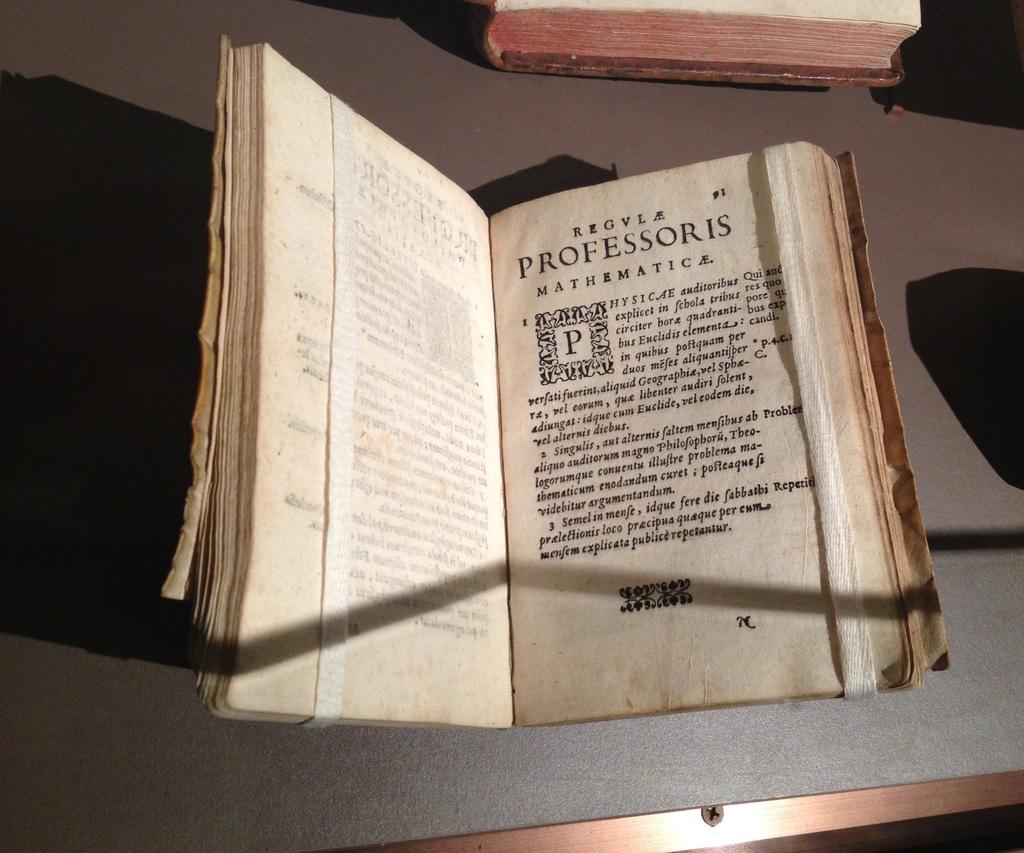What is this book about?
Provide a succinct answer. Unanswerable. What page is showing?
Provide a succinct answer. 91. 